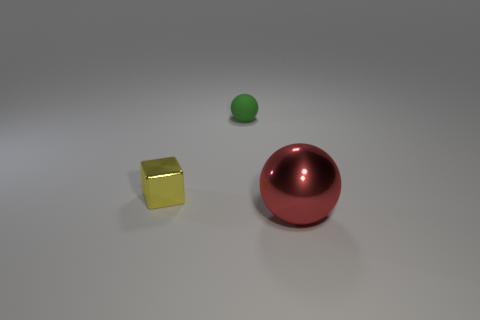Add 2 small green cylinders. How many objects exist? 5 Subtract all blocks. How many objects are left? 2 Subtract all rubber blocks. Subtract all yellow blocks. How many objects are left? 2 Add 3 tiny matte things. How many tiny matte things are left? 4 Add 3 big brown cylinders. How many big brown cylinders exist? 3 Subtract 0 gray cylinders. How many objects are left? 3 